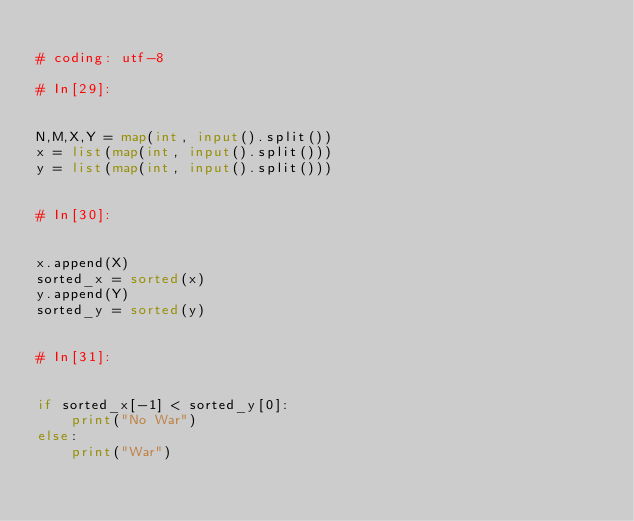Convert code to text. <code><loc_0><loc_0><loc_500><loc_500><_Python_>
# coding: utf-8

# In[29]:


N,M,X,Y = map(int, input().split())
x = list(map(int, input().split()))
y = list(map(int, input().split()))


# In[30]:


x.append(X)
sorted_x = sorted(x)
y.append(Y)
sorted_y = sorted(y)


# In[31]:


if sorted_x[-1] < sorted_y[0]:
    print("No War")
else:
    print("War")

</code> 